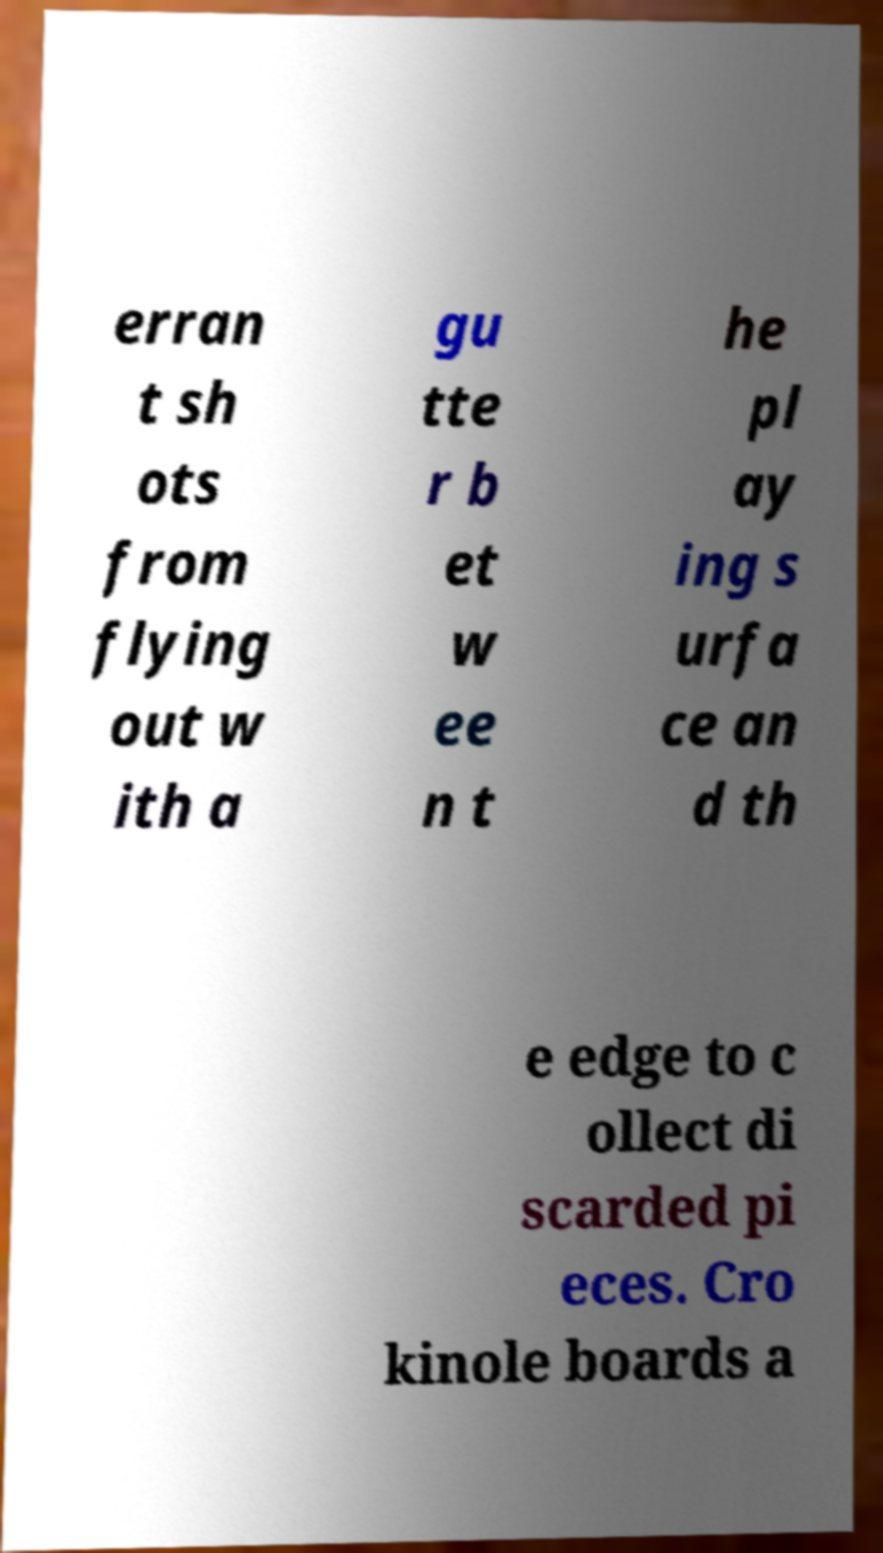Please identify and transcribe the text found in this image. erran t sh ots from flying out w ith a gu tte r b et w ee n t he pl ay ing s urfa ce an d th e edge to c ollect di scarded pi eces. Cro kinole boards a 